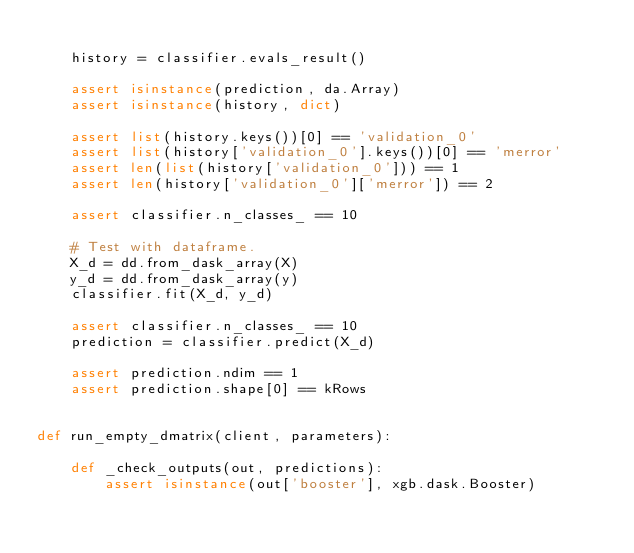Convert code to text. <code><loc_0><loc_0><loc_500><loc_500><_Python_>
    history = classifier.evals_result()

    assert isinstance(prediction, da.Array)
    assert isinstance(history, dict)

    assert list(history.keys())[0] == 'validation_0'
    assert list(history['validation_0'].keys())[0] == 'merror'
    assert len(list(history['validation_0'])) == 1
    assert len(history['validation_0']['merror']) == 2

    assert classifier.n_classes_ == 10

    # Test with dataframe.
    X_d = dd.from_dask_array(X)
    y_d = dd.from_dask_array(y)
    classifier.fit(X_d, y_d)

    assert classifier.n_classes_ == 10
    prediction = classifier.predict(X_d)

    assert prediction.ndim == 1
    assert prediction.shape[0] == kRows


def run_empty_dmatrix(client, parameters):

    def _check_outputs(out, predictions):
        assert isinstance(out['booster'], xgb.dask.Booster)</code> 